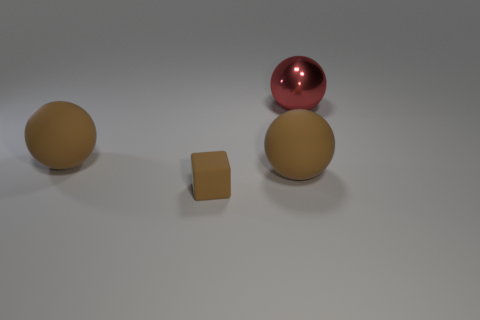Add 4 matte cylinders. How many objects exist? 8 Subtract all cubes. How many objects are left? 3 Add 2 small rubber objects. How many small rubber objects exist? 3 Subtract 0 blue cylinders. How many objects are left? 4 Subtract all matte cubes. Subtract all tiny blocks. How many objects are left? 2 Add 3 red objects. How many red objects are left? 4 